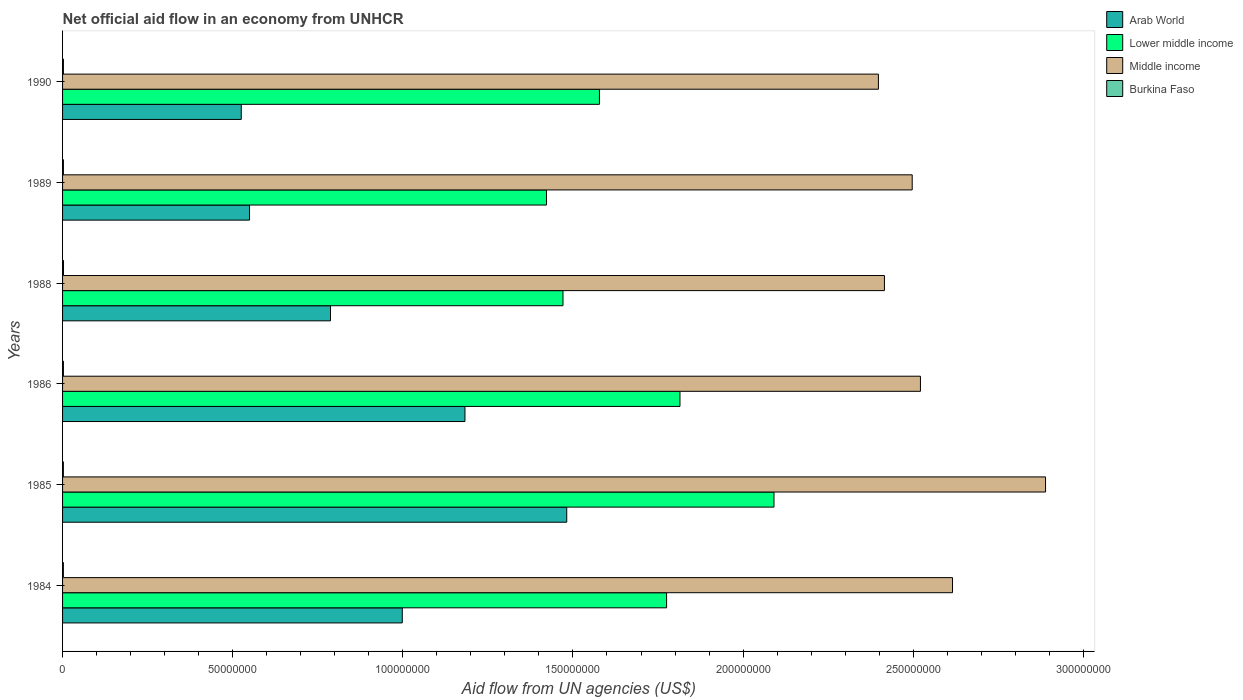How many different coloured bars are there?
Give a very brief answer. 4. How many bars are there on the 5th tick from the top?
Your answer should be very brief. 4. What is the label of the 5th group of bars from the top?
Your answer should be compact. 1985. In how many cases, is the number of bars for a given year not equal to the number of legend labels?
Provide a succinct answer. 0. What is the net official aid flow in Lower middle income in 1985?
Your answer should be compact. 2.09e+08. Across all years, what is the maximum net official aid flow in Arab World?
Your response must be concise. 1.48e+08. Across all years, what is the minimum net official aid flow in Arab World?
Provide a succinct answer. 5.25e+07. In which year was the net official aid flow in Arab World maximum?
Offer a very short reply. 1985. In which year was the net official aid flow in Middle income minimum?
Offer a terse response. 1990. What is the total net official aid flow in Middle income in the graph?
Make the answer very short. 1.53e+09. What is the difference between the net official aid flow in Lower middle income in 1985 and that in 1990?
Ensure brevity in your answer.  5.13e+07. What is the difference between the net official aid flow in Middle income in 1986 and the net official aid flow in Burkina Faso in 1984?
Your response must be concise. 2.52e+08. What is the average net official aid flow in Arab World per year?
Give a very brief answer. 9.21e+07. In the year 1989, what is the difference between the net official aid flow in Burkina Faso and net official aid flow in Arab World?
Ensure brevity in your answer.  -5.47e+07. In how many years, is the net official aid flow in Arab World greater than 120000000 US$?
Give a very brief answer. 1. What is the ratio of the net official aid flow in Burkina Faso in 1985 to that in 1988?
Provide a short and direct response. 0.86. What is the difference between the highest and the second highest net official aid flow in Middle income?
Offer a very short reply. 2.73e+07. What is the difference between the highest and the lowest net official aid flow in Burkina Faso?
Give a very brief answer. 4.00e+04. In how many years, is the net official aid flow in Middle income greater than the average net official aid flow in Middle income taken over all years?
Make the answer very short. 2. Is the sum of the net official aid flow in Arab World in 1986 and 1990 greater than the maximum net official aid flow in Middle income across all years?
Your response must be concise. No. What does the 4th bar from the top in 1984 represents?
Give a very brief answer. Arab World. What does the 2nd bar from the bottom in 1990 represents?
Offer a terse response. Lower middle income. Is it the case that in every year, the sum of the net official aid flow in Arab World and net official aid flow in Middle income is greater than the net official aid flow in Lower middle income?
Make the answer very short. Yes. How many bars are there?
Keep it short and to the point. 24. Are all the bars in the graph horizontal?
Keep it short and to the point. Yes. What is the difference between two consecutive major ticks on the X-axis?
Your response must be concise. 5.00e+07. Are the values on the major ticks of X-axis written in scientific E-notation?
Ensure brevity in your answer.  No. Does the graph contain grids?
Offer a very short reply. No. What is the title of the graph?
Make the answer very short. Net official aid flow in an economy from UNHCR. What is the label or title of the X-axis?
Provide a succinct answer. Aid flow from UN agencies (US$). What is the label or title of the Y-axis?
Your answer should be very brief. Years. What is the Aid flow from UN agencies (US$) of Arab World in 1984?
Ensure brevity in your answer.  9.98e+07. What is the Aid flow from UN agencies (US$) in Lower middle income in 1984?
Keep it short and to the point. 1.78e+08. What is the Aid flow from UN agencies (US$) in Middle income in 1984?
Provide a succinct answer. 2.62e+08. What is the Aid flow from UN agencies (US$) in Burkina Faso in 1984?
Make the answer very short. 2.40e+05. What is the Aid flow from UN agencies (US$) of Arab World in 1985?
Your answer should be very brief. 1.48e+08. What is the Aid flow from UN agencies (US$) of Lower middle income in 1985?
Provide a succinct answer. 2.09e+08. What is the Aid flow from UN agencies (US$) of Middle income in 1985?
Your response must be concise. 2.89e+08. What is the Aid flow from UN agencies (US$) of Arab World in 1986?
Make the answer very short. 1.18e+08. What is the Aid flow from UN agencies (US$) in Lower middle income in 1986?
Offer a terse response. 1.81e+08. What is the Aid flow from UN agencies (US$) in Middle income in 1986?
Your answer should be compact. 2.52e+08. What is the Aid flow from UN agencies (US$) of Arab World in 1988?
Provide a short and direct response. 7.87e+07. What is the Aid flow from UN agencies (US$) of Lower middle income in 1988?
Your answer should be very brief. 1.47e+08. What is the Aid flow from UN agencies (US$) in Middle income in 1988?
Give a very brief answer. 2.42e+08. What is the Aid flow from UN agencies (US$) of Arab World in 1989?
Your response must be concise. 5.50e+07. What is the Aid flow from UN agencies (US$) of Lower middle income in 1989?
Make the answer very short. 1.42e+08. What is the Aid flow from UN agencies (US$) of Middle income in 1989?
Provide a short and direct response. 2.50e+08. What is the Aid flow from UN agencies (US$) of Burkina Faso in 1989?
Provide a succinct answer. 2.50e+05. What is the Aid flow from UN agencies (US$) of Arab World in 1990?
Keep it short and to the point. 5.25e+07. What is the Aid flow from UN agencies (US$) of Lower middle income in 1990?
Your answer should be very brief. 1.58e+08. What is the Aid flow from UN agencies (US$) in Middle income in 1990?
Offer a terse response. 2.40e+08. Across all years, what is the maximum Aid flow from UN agencies (US$) in Arab World?
Provide a short and direct response. 1.48e+08. Across all years, what is the maximum Aid flow from UN agencies (US$) of Lower middle income?
Offer a terse response. 2.09e+08. Across all years, what is the maximum Aid flow from UN agencies (US$) in Middle income?
Offer a terse response. 2.89e+08. Across all years, what is the maximum Aid flow from UN agencies (US$) of Burkina Faso?
Make the answer very short. 2.80e+05. Across all years, what is the minimum Aid flow from UN agencies (US$) of Arab World?
Offer a very short reply. 5.25e+07. Across all years, what is the minimum Aid flow from UN agencies (US$) of Lower middle income?
Ensure brevity in your answer.  1.42e+08. Across all years, what is the minimum Aid flow from UN agencies (US$) in Middle income?
Give a very brief answer. 2.40e+08. What is the total Aid flow from UN agencies (US$) in Arab World in the graph?
Offer a very short reply. 5.52e+08. What is the total Aid flow from UN agencies (US$) in Lower middle income in the graph?
Your answer should be compact. 1.02e+09. What is the total Aid flow from UN agencies (US$) of Middle income in the graph?
Provide a succinct answer. 1.53e+09. What is the total Aid flow from UN agencies (US$) in Burkina Faso in the graph?
Make the answer very short. 1.51e+06. What is the difference between the Aid flow from UN agencies (US$) in Arab World in 1984 and that in 1985?
Your response must be concise. -4.83e+07. What is the difference between the Aid flow from UN agencies (US$) in Lower middle income in 1984 and that in 1985?
Offer a terse response. -3.16e+07. What is the difference between the Aid flow from UN agencies (US$) of Middle income in 1984 and that in 1985?
Provide a short and direct response. -2.73e+07. What is the difference between the Aid flow from UN agencies (US$) in Arab World in 1984 and that in 1986?
Offer a terse response. -1.84e+07. What is the difference between the Aid flow from UN agencies (US$) of Lower middle income in 1984 and that in 1986?
Offer a very short reply. -3.93e+06. What is the difference between the Aid flow from UN agencies (US$) of Middle income in 1984 and that in 1986?
Provide a short and direct response. 9.43e+06. What is the difference between the Aid flow from UN agencies (US$) in Burkina Faso in 1984 and that in 1986?
Provide a succinct answer. -10000. What is the difference between the Aid flow from UN agencies (US$) in Arab World in 1984 and that in 1988?
Offer a terse response. 2.11e+07. What is the difference between the Aid flow from UN agencies (US$) of Lower middle income in 1984 and that in 1988?
Your response must be concise. 3.04e+07. What is the difference between the Aid flow from UN agencies (US$) of Middle income in 1984 and that in 1988?
Ensure brevity in your answer.  2.00e+07. What is the difference between the Aid flow from UN agencies (US$) in Arab World in 1984 and that in 1989?
Make the answer very short. 4.49e+07. What is the difference between the Aid flow from UN agencies (US$) in Lower middle income in 1984 and that in 1989?
Provide a succinct answer. 3.53e+07. What is the difference between the Aid flow from UN agencies (US$) in Middle income in 1984 and that in 1989?
Your answer should be compact. 1.18e+07. What is the difference between the Aid flow from UN agencies (US$) of Burkina Faso in 1984 and that in 1989?
Provide a short and direct response. -10000. What is the difference between the Aid flow from UN agencies (US$) in Arab World in 1984 and that in 1990?
Provide a succinct answer. 4.73e+07. What is the difference between the Aid flow from UN agencies (US$) of Lower middle income in 1984 and that in 1990?
Make the answer very short. 1.97e+07. What is the difference between the Aid flow from UN agencies (US$) in Middle income in 1984 and that in 1990?
Your answer should be very brief. 2.18e+07. What is the difference between the Aid flow from UN agencies (US$) of Burkina Faso in 1984 and that in 1990?
Ensure brevity in your answer.  -10000. What is the difference between the Aid flow from UN agencies (US$) of Arab World in 1985 and that in 1986?
Offer a terse response. 2.99e+07. What is the difference between the Aid flow from UN agencies (US$) in Lower middle income in 1985 and that in 1986?
Your response must be concise. 2.76e+07. What is the difference between the Aid flow from UN agencies (US$) of Middle income in 1985 and that in 1986?
Your response must be concise. 3.68e+07. What is the difference between the Aid flow from UN agencies (US$) in Arab World in 1985 and that in 1988?
Offer a very short reply. 6.94e+07. What is the difference between the Aid flow from UN agencies (US$) in Lower middle income in 1985 and that in 1988?
Make the answer very short. 6.20e+07. What is the difference between the Aid flow from UN agencies (US$) of Middle income in 1985 and that in 1988?
Keep it short and to the point. 4.74e+07. What is the difference between the Aid flow from UN agencies (US$) in Burkina Faso in 1985 and that in 1988?
Ensure brevity in your answer.  -4.00e+04. What is the difference between the Aid flow from UN agencies (US$) in Arab World in 1985 and that in 1989?
Keep it short and to the point. 9.32e+07. What is the difference between the Aid flow from UN agencies (US$) of Lower middle income in 1985 and that in 1989?
Offer a terse response. 6.69e+07. What is the difference between the Aid flow from UN agencies (US$) of Middle income in 1985 and that in 1989?
Make the answer very short. 3.92e+07. What is the difference between the Aid flow from UN agencies (US$) in Burkina Faso in 1985 and that in 1989?
Offer a terse response. -10000. What is the difference between the Aid flow from UN agencies (US$) of Arab World in 1985 and that in 1990?
Your response must be concise. 9.56e+07. What is the difference between the Aid flow from UN agencies (US$) of Lower middle income in 1985 and that in 1990?
Make the answer very short. 5.13e+07. What is the difference between the Aid flow from UN agencies (US$) in Middle income in 1985 and that in 1990?
Your response must be concise. 4.91e+07. What is the difference between the Aid flow from UN agencies (US$) of Burkina Faso in 1985 and that in 1990?
Offer a terse response. -10000. What is the difference between the Aid flow from UN agencies (US$) of Arab World in 1986 and that in 1988?
Provide a short and direct response. 3.95e+07. What is the difference between the Aid flow from UN agencies (US$) of Lower middle income in 1986 and that in 1988?
Make the answer very short. 3.44e+07. What is the difference between the Aid flow from UN agencies (US$) of Middle income in 1986 and that in 1988?
Provide a succinct answer. 1.06e+07. What is the difference between the Aid flow from UN agencies (US$) of Arab World in 1986 and that in 1989?
Give a very brief answer. 6.33e+07. What is the difference between the Aid flow from UN agencies (US$) of Lower middle income in 1986 and that in 1989?
Ensure brevity in your answer.  3.92e+07. What is the difference between the Aid flow from UN agencies (US$) in Middle income in 1986 and that in 1989?
Your answer should be compact. 2.42e+06. What is the difference between the Aid flow from UN agencies (US$) of Burkina Faso in 1986 and that in 1989?
Offer a terse response. 0. What is the difference between the Aid flow from UN agencies (US$) of Arab World in 1986 and that in 1990?
Offer a very short reply. 6.57e+07. What is the difference between the Aid flow from UN agencies (US$) of Lower middle income in 1986 and that in 1990?
Your answer should be very brief. 2.37e+07. What is the difference between the Aid flow from UN agencies (US$) of Middle income in 1986 and that in 1990?
Give a very brief answer. 1.24e+07. What is the difference between the Aid flow from UN agencies (US$) in Arab World in 1988 and that in 1989?
Your answer should be compact. 2.38e+07. What is the difference between the Aid flow from UN agencies (US$) in Lower middle income in 1988 and that in 1989?
Offer a very short reply. 4.85e+06. What is the difference between the Aid flow from UN agencies (US$) in Middle income in 1988 and that in 1989?
Provide a short and direct response. -8.16e+06. What is the difference between the Aid flow from UN agencies (US$) in Burkina Faso in 1988 and that in 1989?
Keep it short and to the point. 3.00e+04. What is the difference between the Aid flow from UN agencies (US$) in Arab World in 1988 and that in 1990?
Offer a terse response. 2.62e+07. What is the difference between the Aid flow from UN agencies (US$) in Lower middle income in 1988 and that in 1990?
Offer a very short reply. -1.07e+07. What is the difference between the Aid flow from UN agencies (US$) in Middle income in 1988 and that in 1990?
Give a very brief answer. 1.77e+06. What is the difference between the Aid flow from UN agencies (US$) of Arab World in 1989 and that in 1990?
Your response must be concise. 2.43e+06. What is the difference between the Aid flow from UN agencies (US$) in Lower middle income in 1989 and that in 1990?
Keep it short and to the point. -1.56e+07. What is the difference between the Aid flow from UN agencies (US$) in Middle income in 1989 and that in 1990?
Provide a succinct answer. 9.93e+06. What is the difference between the Aid flow from UN agencies (US$) in Arab World in 1984 and the Aid flow from UN agencies (US$) in Lower middle income in 1985?
Provide a short and direct response. -1.09e+08. What is the difference between the Aid flow from UN agencies (US$) of Arab World in 1984 and the Aid flow from UN agencies (US$) of Middle income in 1985?
Your answer should be compact. -1.89e+08. What is the difference between the Aid flow from UN agencies (US$) of Arab World in 1984 and the Aid flow from UN agencies (US$) of Burkina Faso in 1985?
Offer a terse response. 9.96e+07. What is the difference between the Aid flow from UN agencies (US$) in Lower middle income in 1984 and the Aid flow from UN agencies (US$) in Middle income in 1985?
Offer a terse response. -1.11e+08. What is the difference between the Aid flow from UN agencies (US$) of Lower middle income in 1984 and the Aid flow from UN agencies (US$) of Burkina Faso in 1985?
Your response must be concise. 1.77e+08. What is the difference between the Aid flow from UN agencies (US$) in Middle income in 1984 and the Aid flow from UN agencies (US$) in Burkina Faso in 1985?
Offer a very short reply. 2.61e+08. What is the difference between the Aid flow from UN agencies (US$) in Arab World in 1984 and the Aid flow from UN agencies (US$) in Lower middle income in 1986?
Give a very brief answer. -8.16e+07. What is the difference between the Aid flow from UN agencies (US$) of Arab World in 1984 and the Aid flow from UN agencies (US$) of Middle income in 1986?
Offer a terse response. -1.52e+08. What is the difference between the Aid flow from UN agencies (US$) in Arab World in 1984 and the Aid flow from UN agencies (US$) in Burkina Faso in 1986?
Keep it short and to the point. 9.96e+07. What is the difference between the Aid flow from UN agencies (US$) in Lower middle income in 1984 and the Aid flow from UN agencies (US$) in Middle income in 1986?
Provide a succinct answer. -7.46e+07. What is the difference between the Aid flow from UN agencies (US$) of Lower middle income in 1984 and the Aid flow from UN agencies (US$) of Burkina Faso in 1986?
Your answer should be very brief. 1.77e+08. What is the difference between the Aid flow from UN agencies (US$) in Middle income in 1984 and the Aid flow from UN agencies (US$) in Burkina Faso in 1986?
Your response must be concise. 2.61e+08. What is the difference between the Aid flow from UN agencies (US$) in Arab World in 1984 and the Aid flow from UN agencies (US$) in Lower middle income in 1988?
Provide a succinct answer. -4.72e+07. What is the difference between the Aid flow from UN agencies (US$) in Arab World in 1984 and the Aid flow from UN agencies (US$) in Middle income in 1988?
Your answer should be very brief. -1.42e+08. What is the difference between the Aid flow from UN agencies (US$) of Arab World in 1984 and the Aid flow from UN agencies (US$) of Burkina Faso in 1988?
Make the answer very short. 9.96e+07. What is the difference between the Aid flow from UN agencies (US$) of Lower middle income in 1984 and the Aid flow from UN agencies (US$) of Middle income in 1988?
Your answer should be compact. -6.40e+07. What is the difference between the Aid flow from UN agencies (US$) in Lower middle income in 1984 and the Aid flow from UN agencies (US$) in Burkina Faso in 1988?
Offer a very short reply. 1.77e+08. What is the difference between the Aid flow from UN agencies (US$) of Middle income in 1984 and the Aid flow from UN agencies (US$) of Burkina Faso in 1988?
Your answer should be very brief. 2.61e+08. What is the difference between the Aid flow from UN agencies (US$) of Arab World in 1984 and the Aid flow from UN agencies (US$) of Lower middle income in 1989?
Ensure brevity in your answer.  -4.24e+07. What is the difference between the Aid flow from UN agencies (US$) in Arab World in 1984 and the Aid flow from UN agencies (US$) in Middle income in 1989?
Make the answer very short. -1.50e+08. What is the difference between the Aid flow from UN agencies (US$) of Arab World in 1984 and the Aid flow from UN agencies (US$) of Burkina Faso in 1989?
Give a very brief answer. 9.96e+07. What is the difference between the Aid flow from UN agencies (US$) of Lower middle income in 1984 and the Aid flow from UN agencies (US$) of Middle income in 1989?
Provide a short and direct response. -7.22e+07. What is the difference between the Aid flow from UN agencies (US$) of Lower middle income in 1984 and the Aid flow from UN agencies (US$) of Burkina Faso in 1989?
Make the answer very short. 1.77e+08. What is the difference between the Aid flow from UN agencies (US$) in Middle income in 1984 and the Aid flow from UN agencies (US$) in Burkina Faso in 1989?
Your answer should be compact. 2.61e+08. What is the difference between the Aid flow from UN agencies (US$) of Arab World in 1984 and the Aid flow from UN agencies (US$) of Lower middle income in 1990?
Offer a very short reply. -5.79e+07. What is the difference between the Aid flow from UN agencies (US$) in Arab World in 1984 and the Aid flow from UN agencies (US$) in Middle income in 1990?
Give a very brief answer. -1.40e+08. What is the difference between the Aid flow from UN agencies (US$) of Arab World in 1984 and the Aid flow from UN agencies (US$) of Burkina Faso in 1990?
Make the answer very short. 9.96e+07. What is the difference between the Aid flow from UN agencies (US$) of Lower middle income in 1984 and the Aid flow from UN agencies (US$) of Middle income in 1990?
Offer a terse response. -6.22e+07. What is the difference between the Aid flow from UN agencies (US$) in Lower middle income in 1984 and the Aid flow from UN agencies (US$) in Burkina Faso in 1990?
Provide a succinct answer. 1.77e+08. What is the difference between the Aid flow from UN agencies (US$) in Middle income in 1984 and the Aid flow from UN agencies (US$) in Burkina Faso in 1990?
Offer a very short reply. 2.61e+08. What is the difference between the Aid flow from UN agencies (US$) of Arab World in 1985 and the Aid flow from UN agencies (US$) of Lower middle income in 1986?
Your answer should be compact. -3.33e+07. What is the difference between the Aid flow from UN agencies (US$) of Arab World in 1985 and the Aid flow from UN agencies (US$) of Middle income in 1986?
Your response must be concise. -1.04e+08. What is the difference between the Aid flow from UN agencies (US$) of Arab World in 1985 and the Aid flow from UN agencies (US$) of Burkina Faso in 1986?
Ensure brevity in your answer.  1.48e+08. What is the difference between the Aid flow from UN agencies (US$) in Lower middle income in 1985 and the Aid flow from UN agencies (US$) in Middle income in 1986?
Provide a short and direct response. -4.30e+07. What is the difference between the Aid flow from UN agencies (US$) of Lower middle income in 1985 and the Aid flow from UN agencies (US$) of Burkina Faso in 1986?
Keep it short and to the point. 2.09e+08. What is the difference between the Aid flow from UN agencies (US$) in Middle income in 1985 and the Aid flow from UN agencies (US$) in Burkina Faso in 1986?
Provide a short and direct response. 2.89e+08. What is the difference between the Aid flow from UN agencies (US$) of Arab World in 1985 and the Aid flow from UN agencies (US$) of Lower middle income in 1988?
Your answer should be compact. 1.10e+06. What is the difference between the Aid flow from UN agencies (US$) in Arab World in 1985 and the Aid flow from UN agencies (US$) in Middle income in 1988?
Provide a short and direct response. -9.34e+07. What is the difference between the Aid flow from UN agencies (US$) of Arab World in 1985 and the Aid flow from UN agencies (US$) of Burkina Faso in 1988?
Provide a short and direct response. 1.48e+08. What is the difference between the Aid flow from UN agencies (US$) of Lower middle income in 1985 and the Aid flow from UN agencies (US$) of Middle income in 1988?
Your answer should be compact. -3.25e+07. What is the difference between the Aid flow from UN agencies (US$) of Lower middle income in 1985 and the Aid flow from UN agencies (US$) of Burkina Faso in 1988?
Provide a short and direct response. 2.09e+08. What is the difference between the Aid flow from UN agencies (US$) of Middle income in 1985 and the Aid flow from UN agencies (US$) of Burkina Faso in 1988?
Keep it short and to the point. 2.89e+08. What is the difference between the Aid flow from UN agencies (US$) in Arab World in 1985 and the Aid flow from UN agencies (US$) in Lower middle income in 1989?
Provide a succinct answer. 5.95e+06. What is the difference between the Aid flow from UN agencies (US$) in Arab World in 1985 and the Aid flow from UN agencies (US$) in Middle income in 1989?
Provide a succinct answer. -1.02e+08. What is the difference between the Aid flow from UN agencies (US$) of Arab World in 1985 and the Aid flow from UN agencies (US$) of Burkina Faso in 1989?
Provide a short and direct response. 1.48e+08. What is the difference between the Aid flow from UN agencies (US$) in Lower middle income in 1985 and the Aid flow from UN agencies (US$) in Middle income in 1989?
Make the answer very short. -4.06e+07. What is the difference between the Aid flow from UN agencies (US$) in Lower middle income in 1985 and the Aid flow from UN agencies (US$) in Burkina Faso in 1989?
Offer a very short reply. 2.09e+08. What is the difference between the Aid flow from UN agencies (US$) in Middle income in 1985 and the Aid flow from UN agencies (US$) in Burkina Faso in 1989?
Ensure brevity in your answer.  2.89e+08. What is the difference between the Aid flow from UN agencies (US$) in Arab World in 1985 and the Aid flow from UN agencies (US$) in Lower middle income in 1990?
Ensure brevity in your answer.  -9.61e+06. What is the difference between the Aid flow from UN agencies (US$) in Arab World in 1985 and the Aid flow from UN agencies (US$) in Middle income in 1990?
Your response must be concise. -9.16e+07. What is the difference between the Aid flow from UN agencies (US$) in Arab World in 1985 and the Aid flow from UN agencies (US$) in Burkina Faso in 1990?
Give a very brief answer. 1.48e+08. What is the difference between the Aid flow from UN agencies (US$) of Lower middle income in 1985 and the Aid flow from UN agencies (US$) of Middle income in 1990?
Provide a succinct answer. -3.07e+07. What is the difference between the Aid flow from UN agencies (US$) in Lower middle income in 1985 and the Aid flow from UN agencies (US$) in Burkina Faso in 1990?
Your answer should be very brief. 2.09e+08. What is the difference between the Aid flow from UN agencies (US$) of Middle income in 1985 and the Aid flow from UN agencies (US$) of Burkina Faso in 1990?
Keep it short and to the point. 2.89e+08. What is the difference between the Aid flow from UN agencies (US$) in Arab World in 1986 and the Aid flow from UN agencies (US$) in Lower middle income in 1988?
Ensure brevity in your answer.  -2.88e+07. What is the difference between the Aid flow from UN agencies (US$) of Arab World in 1986 and the Aid flow from UN agencies (US$) of Middle income in 1988?
Give a very brief answer. -1.23e+08. What is the difference between the Aid flow from UN agencies (US$) in Arab World in 1986 and the Aid flow from UN agencies (US$) in Burkina Faso in 1988?
Your response must be concise. 1.18e+08. What is the difference between the Aid flow from UN agencies (US$) of Lower middle income in 1986 and the Aid flow from UN agencies (US$) of Middle income in 1988?
Keep it short and to the point. -6.01e+07. What is the difference between the Aid flow from UN agencies (US$) in Lower middle income in 1986 and the Aid flow from UN agencies (US$) in Burkina Faso in 1988?
Ensure brevity in your answer.  1.81e+08. What is the difference between the Aid flow from UN agencies (US$) of Middle income in 1986 and the Aid flow from UN agencies (US$) of Burkina Faso in 1988?
Provide a succinct answer. 2.52e+08. What is the difference between the Aid flow from UN agencies (US$) in Arab World in 1986 and the Aid flow from UN agencies (US$) in Lower middle income in 1989?
Provide a short and direct response. -2.40e+07. What is the difference between the Aid flow from UN agencies (US$) in Arab World in 1986 and the Aid flow from UN agencies (US$) in Middle income in 1989?
Your answer should be compact. -1.31e+08. What is the difference between the Aid flow from UN agencies (US$) of Arab World in 1986 and the Aid flow from UN agencies (US$) of Burkina Faso in 1989?
Offer a very short reply. 1.18e+08. What is the difference between the Aid flow from UN agencies (US$) of Lower middle income in 1986 and the Aid flow from UN agencies (US$) of Middle income in 1989?
Offer a terse response. -6.82e+07. What is the difference between the Aid flow from UN agencies (US$) in Lower middle income in 1986 and the Aid flow from UN agencies (US$) in Burkina Faso in 1989?
Offer a terse response. 1.81e+08. What is the difference between the Aid flow from UN agencies (US$) of Middle income in 1986 and the Aid flow from UN agencies (US$) of Burkina Faso in 1989?
Keep it short and to the point. 2.52e+08. What is the difference between the Aid flow from UN agencies (US$) in Arab World in 1986 and the Aid flow from UN agencies (US$) in Lower middle income in 1990?
Make the answer very short. -3.95e+07. What is the difference between the Aid flow from UN agencies (US$) in Arab World in 1986 and the Aid flow from UN agencies (US$) in Middle income in 1990?
Provide a short and direct response. -1.22e+08. What is the difference between the Aid flow from UN agencies (US$) of Arab World in 1986 and the Aid flow from UN agencies (US$) of Burkina Faso in 1990?
Your response must be concise. 1.18e+08. What is the difference between the Aid flow from UN agencies (US$) in Lower middle income in 1986 and the Aid flow from UN agencies (US$) in Middle income in 1990?
Your answer should be very brief. -5.83e+07. What is the difference between the Aid flow from UN agencies (US$) in Lower middle income in 1986 and the Aid flow from UN agencies (US$) in Burkina Faso in 1990?
Your answer should be compact. 1.81e+08. What is the difference between the Aid flow from UN agencies (US$) in Middle income in 1986 and the Aid flow from UN agencies (US$) in Burkina Faso in 1990?
Your answer should be compact. 2.52e+08. What is the difference between the Aid flow from UN agencies (US$) of Arab World in 1988 and the Aid flow from UN agencies (US$) of Lower middle income in 1989?
Your answer should be compact. -6.35e+07. What is the difference between the Aid flow from UN agencies (US$) of Arab World in 1988 and the Aid flow from UN agencies (US$) of Middle income in 1989?
Your response must be concise. -1.71e+08. What is the difference between the Aid flow from UN agencies (US$) of Arab World in 1988 and the Aid flow from UN agencies (US$) of Burkina Faso in 1989?
Make the answer very short. 7.85e+07. What is the difference between the Aid flow from UN agencies (US$) of Lower middle income in 1988 and the Aid flow from UN agencies (US$) of Middle income in 1989?
Offer a terse response. -1.03e+08. What is the difference between the Aid flow from UN agencies (US$) in Lower middle income in 1988 and the Aid flow from UN agencies (US$) in Burkina Faso in 1989?
Ensure brevity in your answer.  1.47e+08. What is the difference between the Aid flow from UN agencies (US$) in Middle income in 1988 and the Aid flow from UN agencies (US$) in Burkina Faso in 1989?
Offer a very short reply. 2.41e+08. What is the difference between the Aid flow from UN agencies (US$) of Arab World in 1988 and the Aid flow from UN agencies (US$) of Lower middle income in 1990?
Ensure brevity in your answer.  -7.90e+07. What is the difference between the Aid flow from UN agencies (US$) in Arab World in 1988 and the Aid flow from UN agencies (US$) in Middle income in 1990?
Offer a terse response. -1.61e+08. What is the difference between the Aid flow from UN agencies (US$) of Arab World in 1988 and the Aid flow from UN agencies (US$) of Burkina Faso in 1990?
Provide a short and direct response. 7.85e+07. What is the difference between the Aid flow from UN agencies (US$) in Lower middle income in 1988 and the Aid flow from UN agencies (US$) in Middle income in 1990?
Give a very brief answer. -9.27e+07. What is the difference between the Aid flow from UN agencies (US$) in Lower middle income in 1988 and the Aid flow from UN agencies (US$) in Burkina Faso in 1990?
Provide a short and direct response. 1.47e+08. What is the difference between the Aid flow from UN agencies (US$) in Middle income in 1988 and the Aid flow from UN agencies (US$) in Burkina Faso in 1990?
Make the answer very short. 2.41e+08. What is the difference between the Aid flow from UN agencies (US$) of Arab World in 1989 and the Aid flow from UN agencies (US$) of Lower middle income in 1990?
Your response must be concise. -1.03e+08. What is the difference between the Aid flow from UN agencies (US$) in Arab World in 1989 and the Aid flow from UN agencies (US$) in Middle income in 1990?
Your answer should be compact. -1.85e+08. What is the difference between the Aid flow from UN agencies (US$) of Arab World in 1989 and the Aid flow from UN agencies (US$) of Burkina Faso in 1990?
Your answer should be very brief. 5.47e+07. What is the difference between the Aid flow from UN agencies (US$) of Lower middle income in 1989 and the Aid flow from UN agencies (US$) of Middle income in 1990?
Ensure brevity in your answer.  -9.76e+07. What is the difference between the Aid flow from UN agencies (US$) of Lower middle income in 1989 and the Aid flow from UN agencies (US$) of Burkina Faso in 1990?
Your answer should be very brief. 1.42e+08. What is the difference between the Aid flow from UN agencies (US$) of Middle income in 1989 and the Aid flow from UN agencies (US$) of Burkina Faso in 1990?
Give a very brief answer. 2.49e+08. What is the average Aid flow from UN agencies (US$) in Arab World per year?
Your answer should be very brief. 9.21e+07. What is the average Aid flow from UN agencies (US$) of Lower middle income per year?
Provide a succinct answer. 1.69e+08. What is the average Aid flow from UN agencies (US$) of Middle income per year?
Provide a succinct answer. 2.56e+08. What is the average Aid flow from UN agencies (US$) in Burkina Faso per year?
Make the answer very short. 2.52e+05. In the year 1984, what is the difference between the Aid flow from UN agencies (US$) in Arab World and Aid flow from UN agencies (US$) in Lower middle income?
Your answer should be very brief. -7.77e+07. In the year 1984, what is the difference between the Aid flow from UN agencies (US$) in Arab World and Aid flow from UN agencies (US$) in Middle income?
Make the answer very short. -1.62e+08. In the year 1984, what is the difference between the Aid flow from UN agencies (US$) in Arab World and Aid flow from UN agencies (US$) in Burkina Faso?
Keep it short and to the point. 9.96e+07. In the year 1984, what is the difference between the Aid flow from UN agencies (US$) in Lower middle income and Aid flow from UN agencies (US$) in Middle income?
Make the answer very short. -8.40e+07. In the year 1984, what is the difference between the Aid flow from UN agencies (US$) in Lower middle income and Aid flow from UN agencies (US$) in Burkina Faso?
Keep it short and to the point. 1.77e+08. In the year 1984, what is the difference between the Aid flow from UN agencies (US$) in Middle income and Aid flow from UN agencies (US$) in Burkina Faso?
Provide a short and direct response. 2.61e+08. In the year 1985, what is the difference between the Aid flow from UN agencies (US$) in Arab World and Aid flow from UN agencies (US$) in Lower middle income?
Keep it short and to the point. -6.09e+07. In the year 1985, what is the difference between the Aid flow from UN agencies (US$) in Arab World and Aid flow from UN agencies (US$) in Middle income?
Offer a very short reply. -1.41e+08. In the year 1985, what is the difference between the Aid flow from UN agencies (US$) of Arab World and Aid flow from UN agencies (US$) of Burkina Faso?
Your response must be concise. 1.48e+08. In the year 1985, what is the difference between the Aid flow from UN agencies (US$) in Lower middle income and Aid flow from UN agencies (US$) in Middle income?
Make the answer very short. -7.98e+07. In the year 1985, what is the difference between the Aid flow from UN agencies (US$) of Lower middle income and Aid flow from UN agencies (US$) of Burkina Faso?
Provide a short and direct response. 2.09e+08. In the year 1985, what is the difference between the Aid flow from UN agencies (US$) of Middle income and Aid flow from UN agencies (US$) of Burkina Faso?
Your answer should be very brief. 2.89e+08. In the year 1986, what is the difference between the Aid flow from UN agencies (US$) in Arab World and Aid flow from UN agencies (US$) in Lower middle income?
Make the answer very short. -6.32e+07. In the year 1986, what is the difference between the Aid flow from UN agencies (US$) of Arab World and Aid flow from UN agencies (US$) of Middle income?
Ensure brevity in your answer.  -1.34e+08. In the year 1986, what is the difference between the Aid flow from UN agencies (US$) in Arab World and Aid flow from UN agencies (US$) in Burkina Faso?
Provide a succinct answer. 1.18e+08. In the year 1986, what is the difference between the Aid flow from UN agencies (US$) of Lower middle income and Aid flow from UN agencies (US$) of Middle income?
Provide a short and direct response. -7.07e+07. In the year 1986, what is the difference between the Aid flow from UN agencies (US$) of Lower middle income and Aid flow from UN agencies (US$) of Burkina Faso?
Provide a short and direct response. 1.81e+08. In the year 1986, what is the difference between the Aid flow from UN agencies (US$) of Middle income and Aid flow from UN agencies (US$) of Burkina Faso?
Keep it short and to the point. 2.52e+08. In the year 1988, what is the difference between the Aid flow from UN agencies (US$) in Arab World and Aid flow from UN agencies (US$) in Lower middle income?
Keep it short and to the point. -6.83e+07. In the year 1988, what is the difference between the Aid flow from UN agencies (US$) in Arab World and Aid flow from UN agencies (US$) in Middle income?
Offer a very short reply. -1.63e+08. In the year 1988, what is the difference between the Aid flow from UN agencies (US$) of Arab World and Aid flow from UN agencies (US$) of Burkina Faso?
Make the answer very short. 7.85e+07. In the year 1988, what is the difference between the Aid flow from UN agencies (US$) of Lower middle income and Aid flow from UN agencies (US$) of Middle income?
Your answer should be compact. -9.45e+07. In the year 1988, what is the difference between the Aid flow from UN agencies (US$) in Lower middle income and Aid flow from UN agencies (US$) in Burkina Faso?
Ensure brevity in your answer.  1.47e+08. In the year 1988, what is the difference between the Aid flow from UN agencies (US$) in Middle income and Aid flow from UN agencies (US$) in Burkina Faso?
Make the answer very short. 2.41e+08. In the year 1989, what is the difference between the Aid flow from UN agencies (US$) of Arab World and Aid flow from UN agencies (US$) of Lower middle income?
Make the answer very short. -8.73e+07. In the year 1989, what is the difference between the Aid flow from UN agencies (US$) of Arab World and Aid flow from UN agencies (US$) of Middle income?
Ensure brevity in your answer.  -1.95e+08. In the year 1989, what is the difference between the Aid flow from UN agencies (US$) of Arab World and Aid flow from UN agencies (US$) of Burkina Faso?
Give a very brief answer. 5.47e+07. In the year 1989, what is the difference between the Aid flow from UN agencies (US$) of Lower middle income and Aid flow from UN agencies (US$) of Middle income?
Your answer should be very brief. -1.07e+08. In the year 1989, what is the difference between the Aid flow from UN agencies (US$) of Lower middle income and Aid flow from UN agencies (US$) of Burkina Faso?
Keep it short and to the point. 1.42e+08. In the year 1989, what is the difference between the Aid flow from UN agencies (US$) of Middle income and Aid flow from UN agencies (US$) of Burkina Faso?
Offer a terse response. 2.49e+08. In the year 1990, what is the difference between the Aid flow from UN agencies (US$) of Arab World and Aid flow from UN agencies (US$) of Lower middle income?
Ensure brevity in your answer.  -1.05e+08. In the year 1990, what is the difference between the Aid flow from UN agencies (US$) of Arab World and Aid flow from UN agencies (US$) of Middle income?
Provide a succinct answer. -1.87e+08. In the year 1990, what is the difference between the Aid flow from UN agencies (US$) of Arab World and Aid flow from UN agencies (US$) of Burkina Faso?
Provide a succinct answer. 5.23e+07. In the year 1990, what is the difference between the Aid flow from UN agencies (US$) of Lower middle income and Aid flow from UN agencies (US$) of Middle income?
Your answer should be compact. -8.20e+07. In the year 1990, what is the difference between the Aid flow from UN agencies (US$) of Lower middle income and Aid flow from UN agencies (US$) of Burkina Faso?
Give a very brief answer. 1.58e+08. In the year 1990, what is the difference between the Aid flow from UN agencies (US$) of Middle income and Aid flow from UN agencies (US$) of Burkina Faso?
Provide a succinct answer. 2.40e+08. What is the ratio of the Aid flow from UN agencies (US$) of Arab World in 1984 to that in 1985?
Provide a short and direct response. 0.67. What is the ratio of the Aid flow from UN agencies (US$) in Lower middle income in 1984 to that in 1985?
Offer a very short reply. 0.85. What is the ratio of the Aid flow from UN agencies (US$) of Middle income in 1984 to that in 1985?
Give a very brief answer. 0.91. What is the ratio of the Aid flow from UN agencies (US$) of Arab World in 1984 to that in 1986?
Provide a short and direct response. 0.84. What is the ratio of the Aid flow from UN agencies (US$) of Lower middle income in 1984 to that in 1986?
Your response must be concise. 0.98. What is the ratio of the Aid flow from UN agencies (US$) of Middle income in 1984 to that in 1986?
Provide a succinct answer. 1.04. What is the ratio of the Aid flow from UN agencies (US$) in Burkina Faso in 1984 to that in 1986?
Provide a short and direct response. 0.96. What is the ratio of the Aid flow from UN agencies (US$) of Arab World in 1984 to that in 1988?
Provide a short and direct response. 1.27. What is the ratio of the Aid flow from UN agencies (US$) in Lower middle income in 1984 to that in 1988?
Offer a very short reply. 1.21. What is the ratio of the Aid flow from UN agencies (US$) in Middle income in 1984 to that in 1988?
Offer a very short reply. 1.08. What is the ratio of the Aid flow from UN agencies (US$) of Arab World in 1984 to that in 1989?
Your answer should be compact. 1.82. What is the ratio of the Aid flow from UN agencies (US$) of Lower middle income in 1984 to that in 1989?
Your answer should be compact. 1.25. What is the ratio of the Aid flow from UN agencies (US$) of Middle income in 1984 to that in 1989?
Give a very brief answer. 1.05. What is the ratio of the Aid flow from UN agencies (US$) of Arab World in 1984 to that in 1990?
Keep it short and to the point. 1.9. What is the ratio of the Aid flow from UN agencies (US$) in Lower middle income in 1984 to that in 1990?
Keep it short and to the point. 1.13. What is the ratio of the Aid flow from UN agencies (US$) of Middle income in 1984 to that in 1990?
Keep it short and to the point. 1.09. What is the ratio of the Aid flow from UN agencies (US$) of Arab World in 1985 to that in 1986?
Provide a succinct answer. 1.25. What is the ratio of the Aid flow from UN agencies (US$) of Lower middle income in 1985 to that in 1986?
Keep it short and to the point. 1.15. What is the ratio of the Aid flow from UN agencies (US$) of Middle income in 1985 to that in 1986?
Offer a very short reply. 1.15. What is the ratio of the Aid flow from UN agencies (US$) of Arab World in 1985 to that in 1988?
Ensure brevity in your answer.  1.88. What is the ratio of the Aid flow from UN agencies (US$) of Lower middle income in 1985 to that in 1988?
Your answer should be compact. 1.42. What is the ratio of the Aid flow from UN agencies (US$) of Middle income in 1985 to that in 1988?
Ensure brevity in your answer.  1.2. What is the ratio of the Aid flow from UN agencies (US$) of Burkina Faso in 1985 to that in 1988?
Your answer should be compact. 0.86. What is the ratio of the Aid flow from UN agencies (US$) in Arab World in 1985 to that in 1989?
Offer a terse response. 2.7. What is the ratio of the Aid flow from UN agencies (US$) of Lower middle income in 1985 to that in 1989?
Make the answer very short. 1.47. What is the ratio of the Aid flow from UN agencies (US$) of Middle income in 1985 to that in 1989?
Give a very brief answer. 1.16. What is the ratio of the Aid flow from UN agencies (US$) in Arab World in 1985 to that in 1990?
Keep it short and to the point. 2.82. What is the ratio of the Aid flow from UN agencies (US$) in Lower middle income in 1985 to that in 1990?
Ensure brevity in your answer.  1.33. What is the ratio of the Aid flow from UN agencies (US$) of Middle income in 1985 to that in 1990?
Your answer should be very brief. 1.2. What is the ratio of the Aid flow from UN agencies (US$) in Burkina Faso in 1985 to that in 1990?
Offer a terse response. 0.96. What is the ratio of the Aid flow from UN agencies (US$) in Arab World in 1986 to that in 1988?
Provide a succinct answer. 1.5. What is the ratio of the Aid flow from UN agencies (US$) of Lower middle income in 1986 to that in 1988?
Offer a terse response. 1.23. What is the ratio of the Aid flow from UN agencies (US$) in Middle income in 1986 to that in 1988?
Offer a very short reply. 1.04. What is the ratio of the Aid flow from UN agencies (US$) of Burkina Faso in 1986 to that in 1988?
Offer a terse response. 0.89. What is the ratio of the Aid flow from UN agencies (US$) of Arab World in 1986 to that in 1989?
Provide a succinct answer. 2.15. What is the ratio of the Aid flow from UN agencies (US$) in Lower middle income in 1986 to that in 1989?
Give a very brief answer. 1.28. What is the ratio of the Aid flow from UN agencies (US$) of Middle income in 1986 to that in 1989?
Make the answer very short. 1.01. What is the ratio of the Aid flow from UN agencies (US$) of Burkina Faso in 1986 to that in 1989?
Ensure brevity in your answer.  1. What is the ratio of the Aid flow from UN agencies (US$) of Arab World in 1986 to that in 1990?
Keep it short and to the point. 2.25. What is the ratio of the Aid flow from UN agencies (US$) in Lower middle income in 1986 to that in 1990?
Keep it short and to the point. 1.15. What is the ratio of the Aid flow from UN agencies (US$) of Middle income in 1986 to that in 1990?
Provide a succinct answer. 1.05. What is the ratio of the Aid flow from UN agencies (US$) in Arab World in 1988 to that in 1989?
Offer a terse response. 1.43. What is the ratio of the Aid flow from UN agencies (US$) in Lower middle income in 1988 to that in 1989?
Your answer should be very brief. 1.03. What is the ratio of the Aid flow from UN agencies (US$) of Middle income in 1988 to that in 1989?
Your response must be concise. 0.97. What is the ratio of the Aid flow from UN agencies (US$) of Burkina Faso in 1988 to that in 1989?
Give a very brief answer. 1.12. What is the ratio of the Aid flow from UN agencies (US$) in Arab World in 1988 to that in 1990?
Make the answer very short. 1.5. What is the ratio of the Aid flow from UN agencies (US$) of Lower middle income in 1988 to that in 1990?
Offer a terse response. 0.93. What is the ratio of the Aid flow from UN agencies (US$) of Middle income in 1988 to that in 1990?
Provide a short and direct response. 1.01. What is the ratio of the Aid flow from UN agencies (US$) of Burkina Faso in 1988 to that in 1990?
Make the answer very short. 1.12. What is the ratio of the Aid flow from UN agencies (US$) in Arab World in 1989 to that in 1990?
Ensure brevity in your answer.  1.05. What is the ratio of the Aid flow from UN agencies (US$) of Lower middle income in 1989 to that in 1990?
Offer a very short reply. 0.9. What is the ratio of the Aid flow from UN agencies (US$) of Middle income in 1989 to that in 1990?
Make the answer very short. 1.04. What is the ratio of the Aid flow from UN agencies (US$) of Burkina Faso in 1989 to that in 1990?
Give a very brief answer. 1. What is the difference between the highest and the second highest Aid flow from UN agencies (US$) of Arab World?
Your response must be concise. 2.99e+07. What is the difference between the highest and the second highest Aid flow from UN agencies (US$) of Lower middle income?
Your response must be concise. 2.76e+07. What is the difference between the highest and the second highest Aid flow from UN agencies (US$) in Middle income?
Give a very brief answer. 2.73e+07. What is the difference between the highest and the lowest Aid flow from UN agencies (US$) of Arab World?
Make the answer very short. 9.56e+07. What is the difference between the highest and the lowest Aid flow from UN agencies (US$) in Lower middle income?
Give a very brief answer. 6.69e+07. What is the difference between the highest and the lowest Aid flow from UN agencies (US$) in Middle income?
Your response must be concise. 4.91e+07. What is the difference between the highest and the lowest Aid flow from UN agencies (US$) in Burkina Faso?
Ensure brevity in your answer.  4.00e+04. 